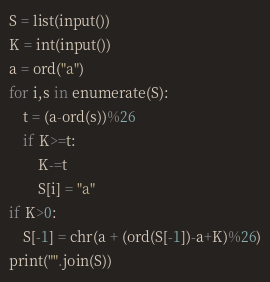Convert code to text. <code><loc_0><loc_0><loc_500><loc_500><_Python_>S = list(input())
K = int(input())
a = ord("a")
for i,s in enumerate(S):
    t = (a-ord(s))%26
    if K>=t:
        K-=t
        S[i] = "a"
if K>0:
    S[-1] = chr(a + (ord(S[-1])-a+K)%26)
print("".join(S))</code> 